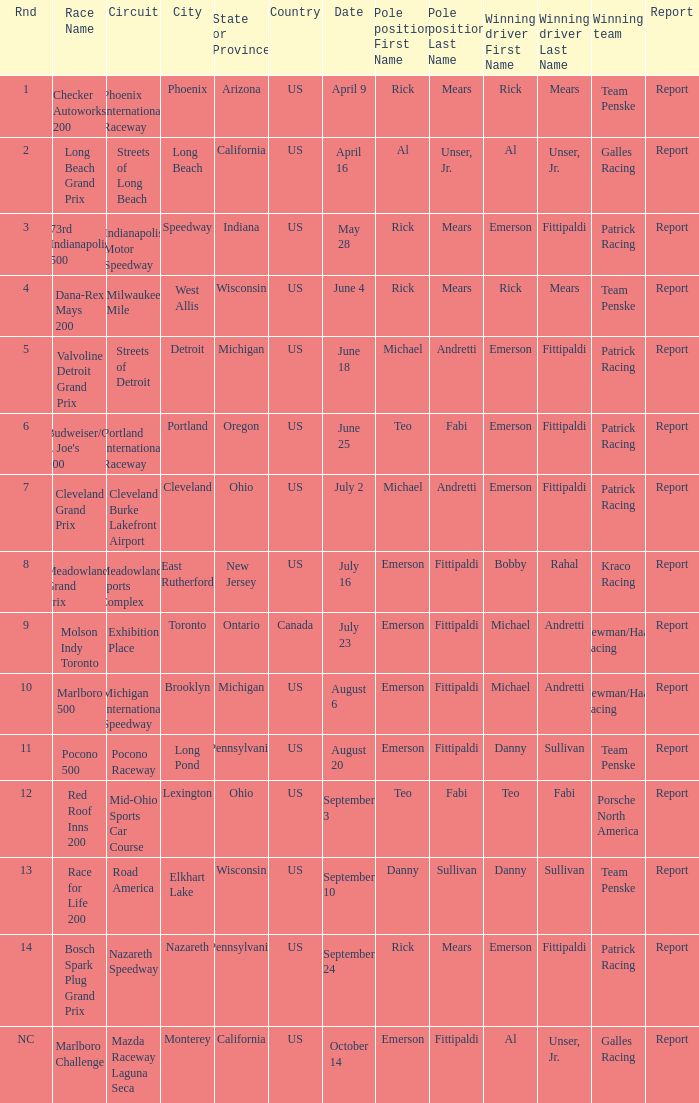What rnds were there for the phoenix international raceway? 1.0. 